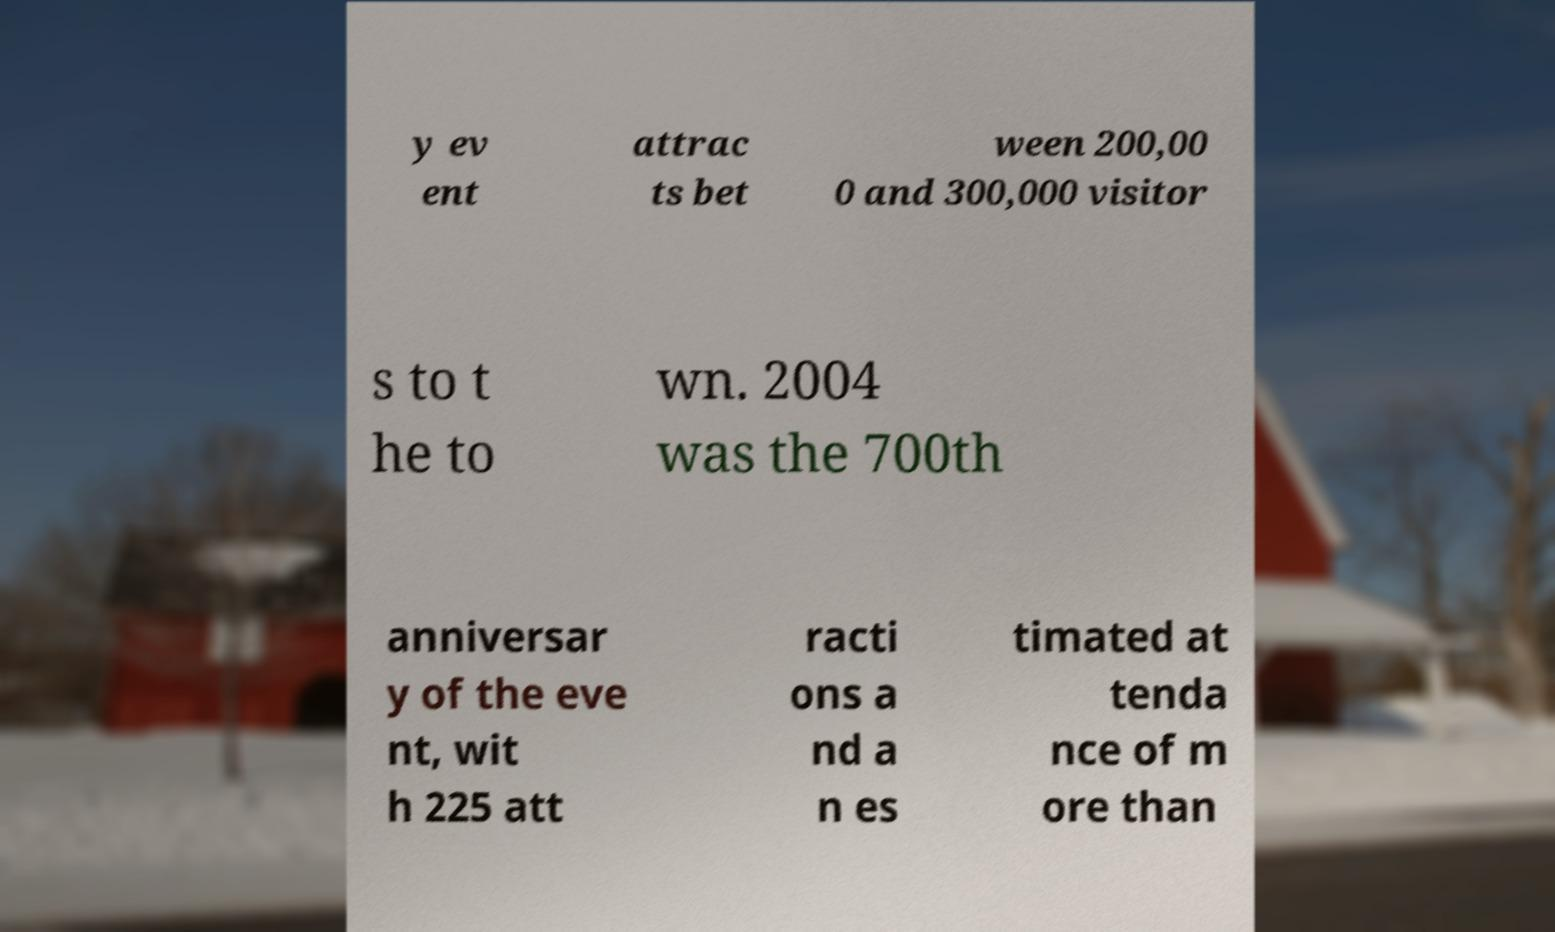I need the written content from this picture converted into text. Can you do that? y ev ent attrac ts bet ween 200,00 0 and 300,000 visitor s to t he to wn. 2004 was the 700th anniversar y of the eve nt, wit h 225 att racti ons a nd a n es timated at tenda nce of m ore than 